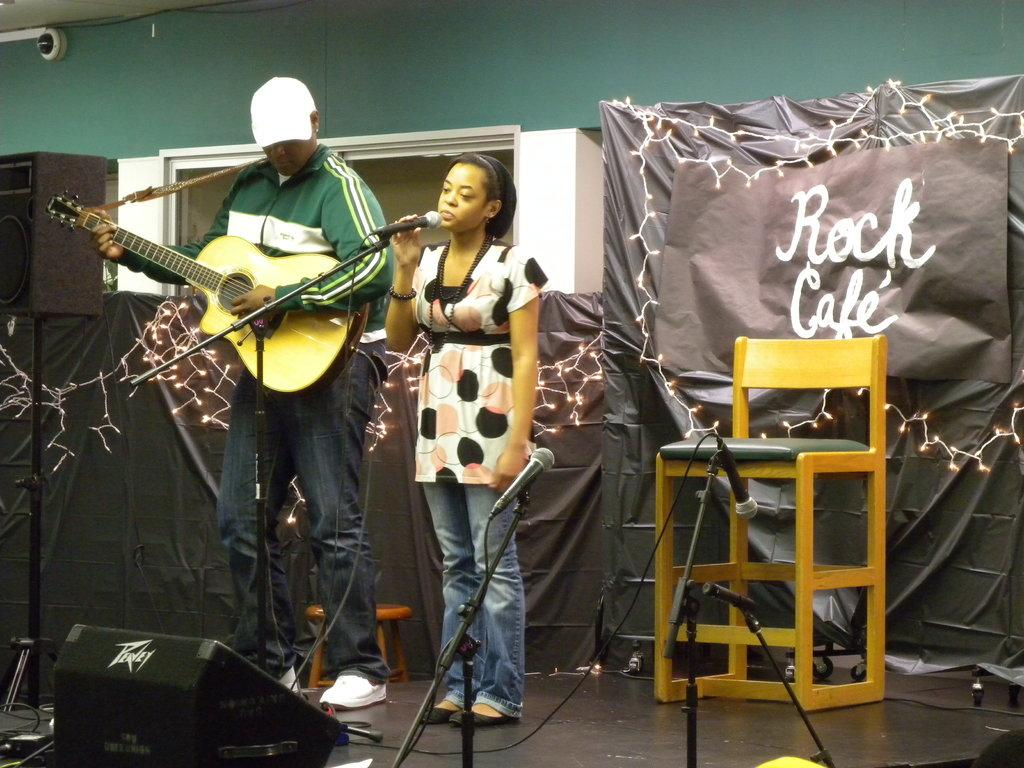What is the man in the image doing? The man is holding a guitar and playing it. What is the woman in the image doing? The woman is singing on a microphone. What objects can be seen in the background of the image? There are speakers, a wall, a cloth, a banner, and a chair in the background of the image. What type of wrench is the actor using in the image? There is no actor or wrench present in the image. How does the man stretch his arms while playing the guitar in the image? The man is not stretching his arms in the image; he is simply playing the guitar. 